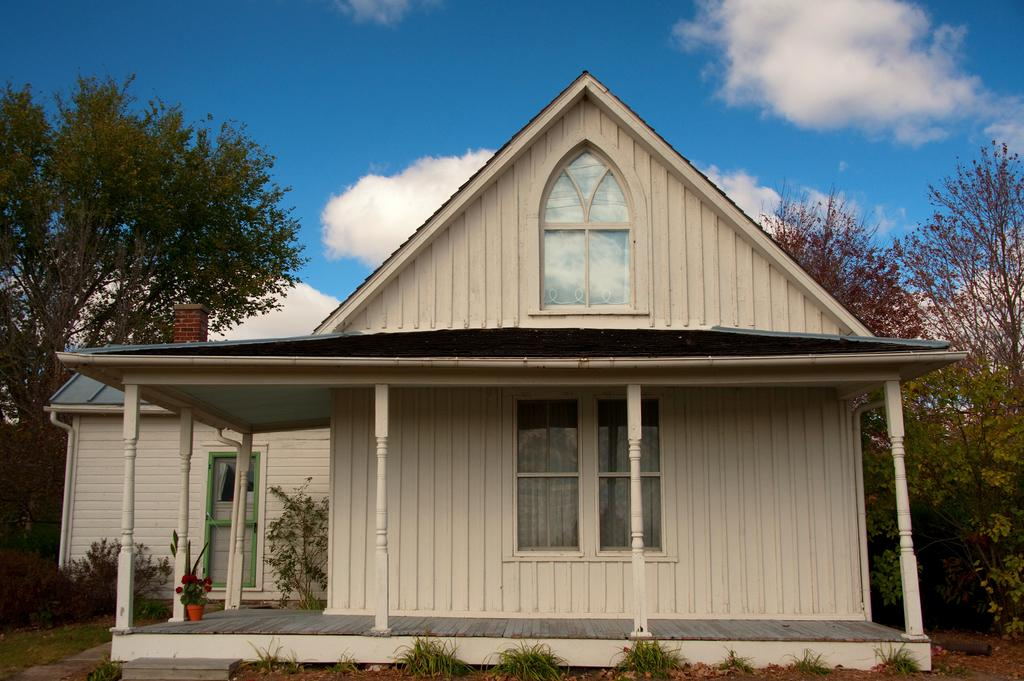What type of house is shown in the picture? There is a house made of wood in the picture. What can be seen near the house? Green trees are planted beside the house. How would you describe the sky in the picture? The sky is clear and blue in the picture. What type of print can be seen on the chair in the picture? There is no chair present in the picture, so it is not possible to determine the type of print on it. 